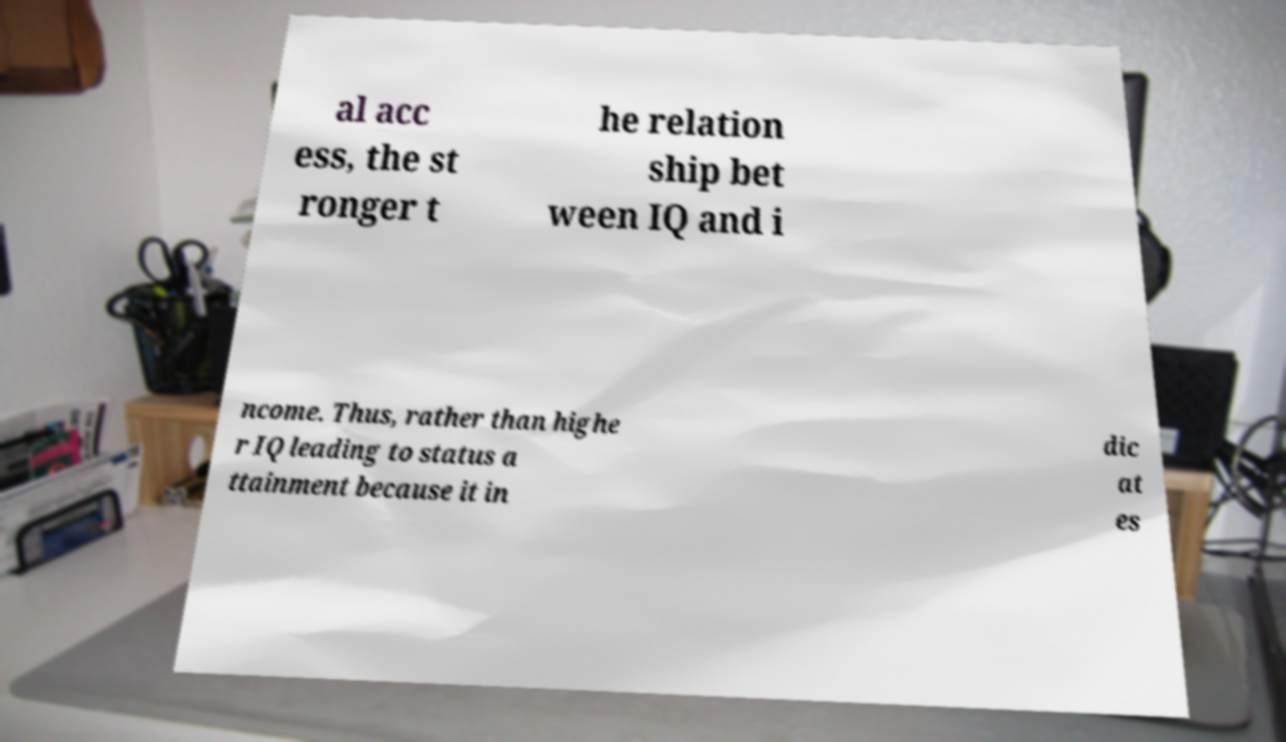Please identify and transcribe the text found in this image. al acc ess, the st ronger t he relation ship bet ween IQ and i ncome. Thus, rather than highe r IQ leading to status a ttainment because it in dic at es 